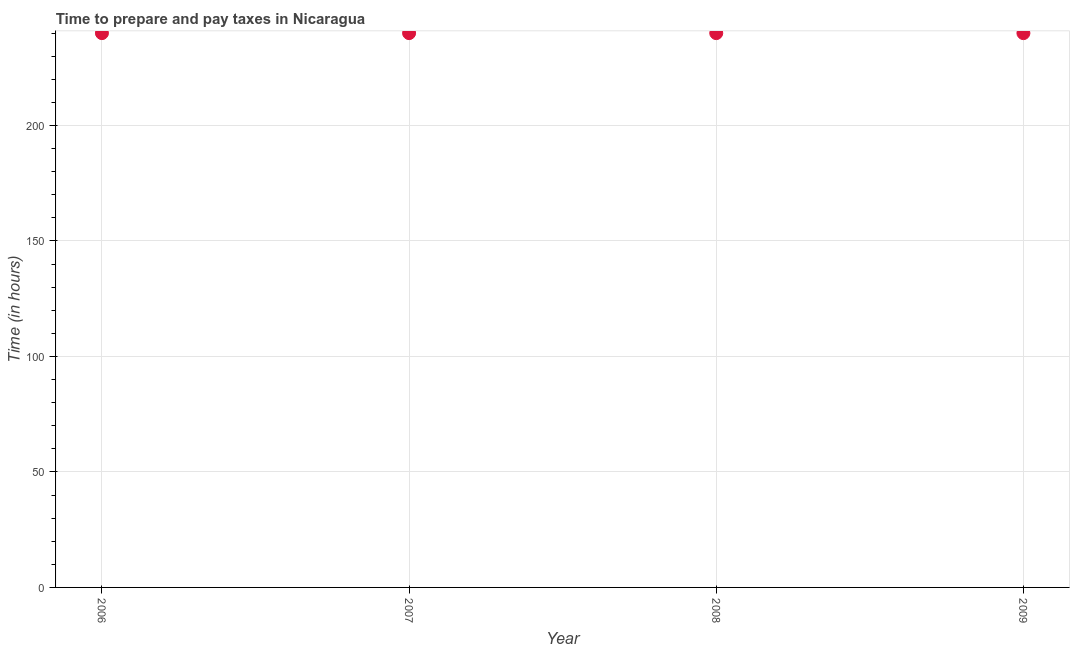What is the time to prepare and pay taxes in 2008?
Offer a terse response. 240. Across all years, what is the maximum time to prepare and pay taxes?
Provide a short and direct response. 240. Across all years, what is the minimum time to prepare and pay taxes?
Offer a terse response. 240. What is the sum of the time to prepare and pay taxes?
Keep it short and to the point. 960. What is the average time to prepare and pay taxes per year?
Provide a succinct answer. 240. What is the median time to prepare and pay taxes?
Offer a terse response. 240. In how many years, is the time to prepare and pay taxes greater than 120 hours?
Offer a terse response. 4. Do a majority of the years between 2009 and 2008 (inclusive) have time to prepare and pay taxes greater than 40 hours?
Provide a short and direct response. No. What is the ratio of the time to prepare and pay taxes in 2006 to that in 2008?
Offer a very short reply. 1. Is the time to prepare and pay taxes in 2008 less than that in 2009?
Your answer should be very brief. No. Is the sum of the time to prepare and pay taxes in 2007 and 2008 greater than the maximum time to prepare and pay taxes across all years?
Provide a short and direct response. Yes. In how many years, is the time to prepare and pay taxes greater than the average time to prepare and pay taxes taken over all years?
Make the answer very short. 0. How many years are there in the graph?
Offer a very short reply. 4. Are the values on the major ticks of Y-axis written in scientific E-notation?
Offer a terse response. No. What is the title of the graph?
Make the answer very short. Time to prepare and pay taxes in Nicaragua. What is the label or title of the X-axis?
Keep it short and to the point. Year. What is the label or title of the Y-axis?
Offer a terse response. Time (in hours). What is the Time (in hours) in 2006?
Ensure brevity in your answer.  240. What is the Time (in hours) in 2007?
Offer a terse response. 240. What is the Time (in hours) in 2008?
Provide a short and direct response. 240. What is the Time (in hours) in 2009?
Give a very brief answer. 240. What is the difference between the Time (in hours) in 2006 and 2007?
Provide a short and direct response. 0. What is the difference between the Time (in hours) in 2006 and 2008?
Provide a succinct answer. 0. What is the difference between the Time (in hours) in 2007 and 2008?
Keep it short and to the point. 0. What is the difference between the Time (in hours) in 2008 and 2009?
Ensure brevity in your answer.  0. What is the ratio of the Time (in hours) in 2006 to that in 2007?
Ensure brevity in your answer.  1. What is the ratio of the Time (in hours) in 2006 to that in 2008?
Provide a short and direct response. 1. What is the ratio of the Time (in hours) in 2006 to that in 2009?
Your response must be concise. 1. What is the ratio of the Time (in hours) in 2007 to that in 2008?
Your answer should be compact. 1. What is the ratio of the Time (in hours) in 2008 to that in 2009?
Offer a very short reply. 1. 